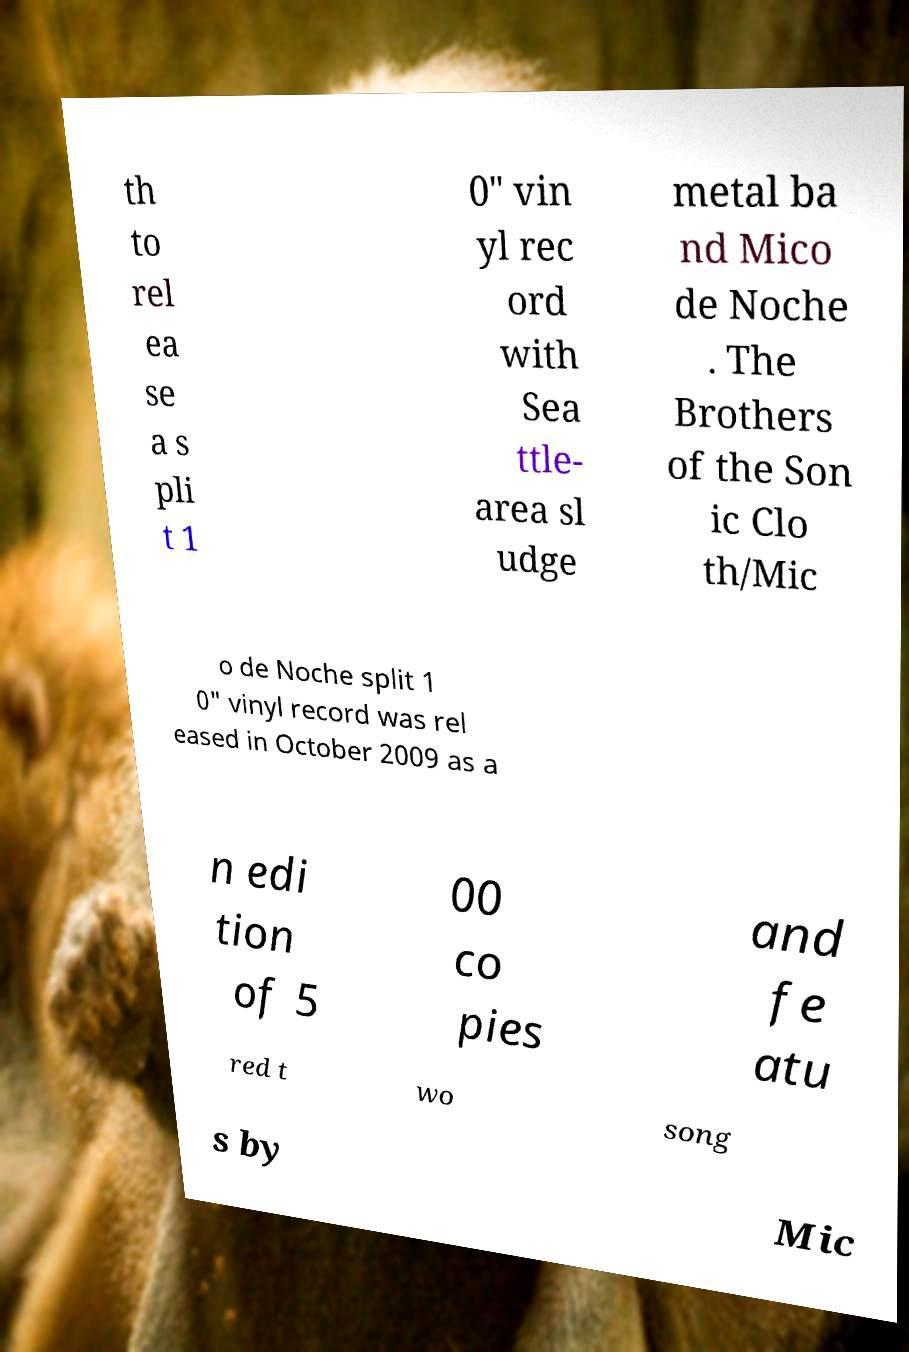For documentation purposes, I need the text within this image transcribed. Could you provide that? th to rel ea se a s pli t 1 0" vin yl rec ord with Sea ttle- area sl udge metal ba nd Mico de Noche . The Brothers of the Son ic Clo th/Mic o de Noche split 1 0" vinyl record was rel eased in October 2009 as a n edi tion of 5 00 co pies and fe atu red t wo song s by Mic 